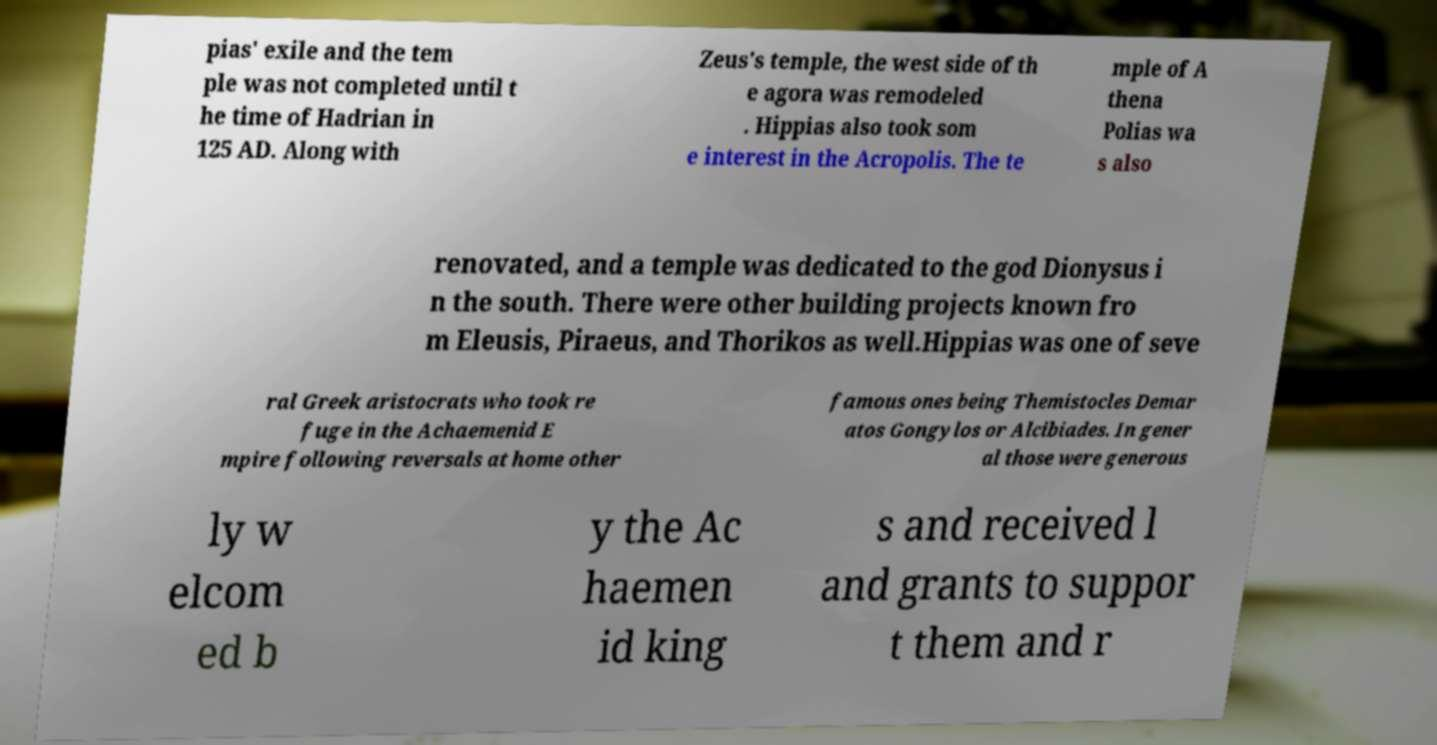For documentation purposes, I need the text within this image transcribed. Could you provide that? pias' exile and the tem ple was not completed until t he time of Hadrian in 125 AD. Along with Zeus's temple, the west side of th e agora was remodeled . Hippias also took som e interest in the Acropolis. The te mple of A thena Polias wa s also renovated, and a temple was dedicated to the god Dionysus i n the south. There were other building projects known fro m Eleusis, Piraeus, and Thorikos as well.Hippias was one of seve ral Greek aristocrats who took re fuge in the Achaemenid E mpire following reversals at home other famous ones being Themistocles Demar atos Gongylos or Alcibiades. In gener al those were generous ly w elcom ed b y the Ac haemen id king s and received l and grants to suppor t them and r 